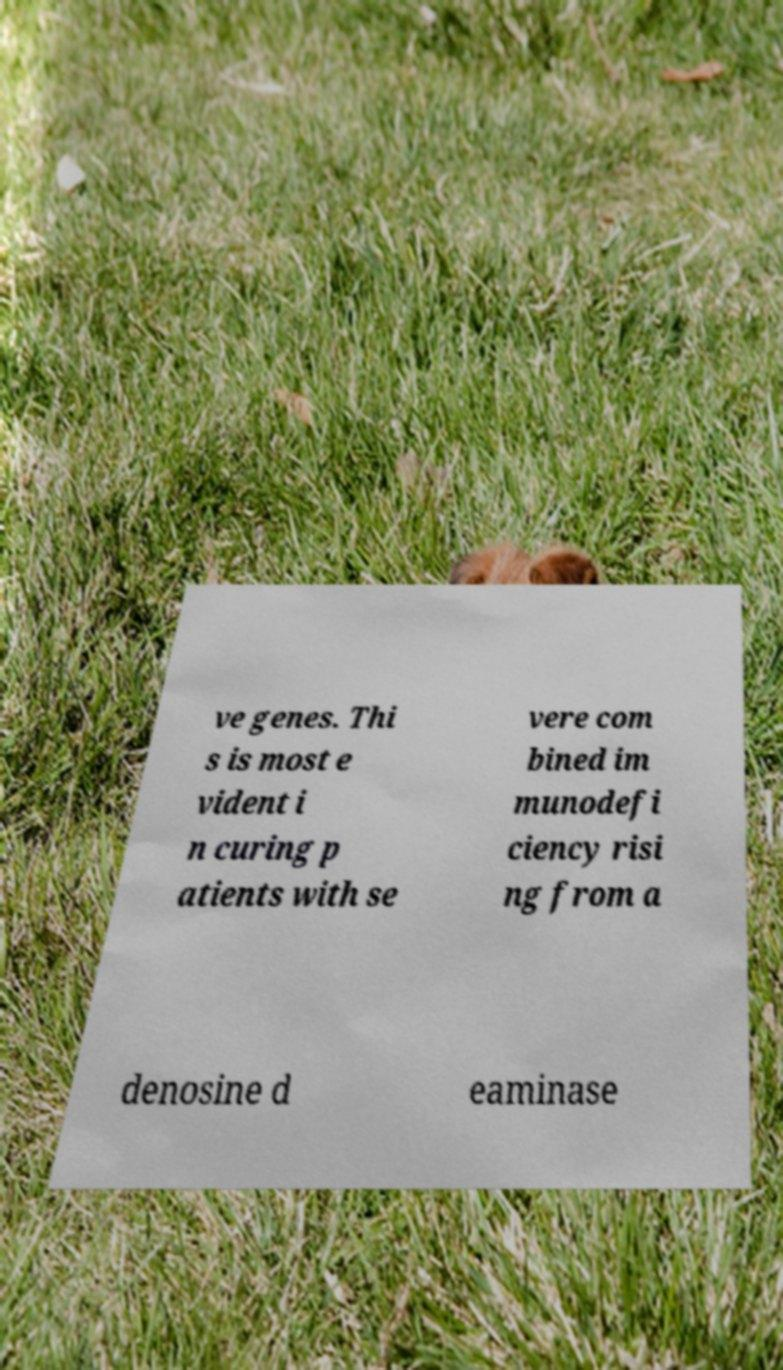I need the written content from this picture converted into text. Can you do that? ve genes. Thi s is most e vident i n curing p atients with se vere com bined im munodefi ciency risi ng from a denosine d eaminase 